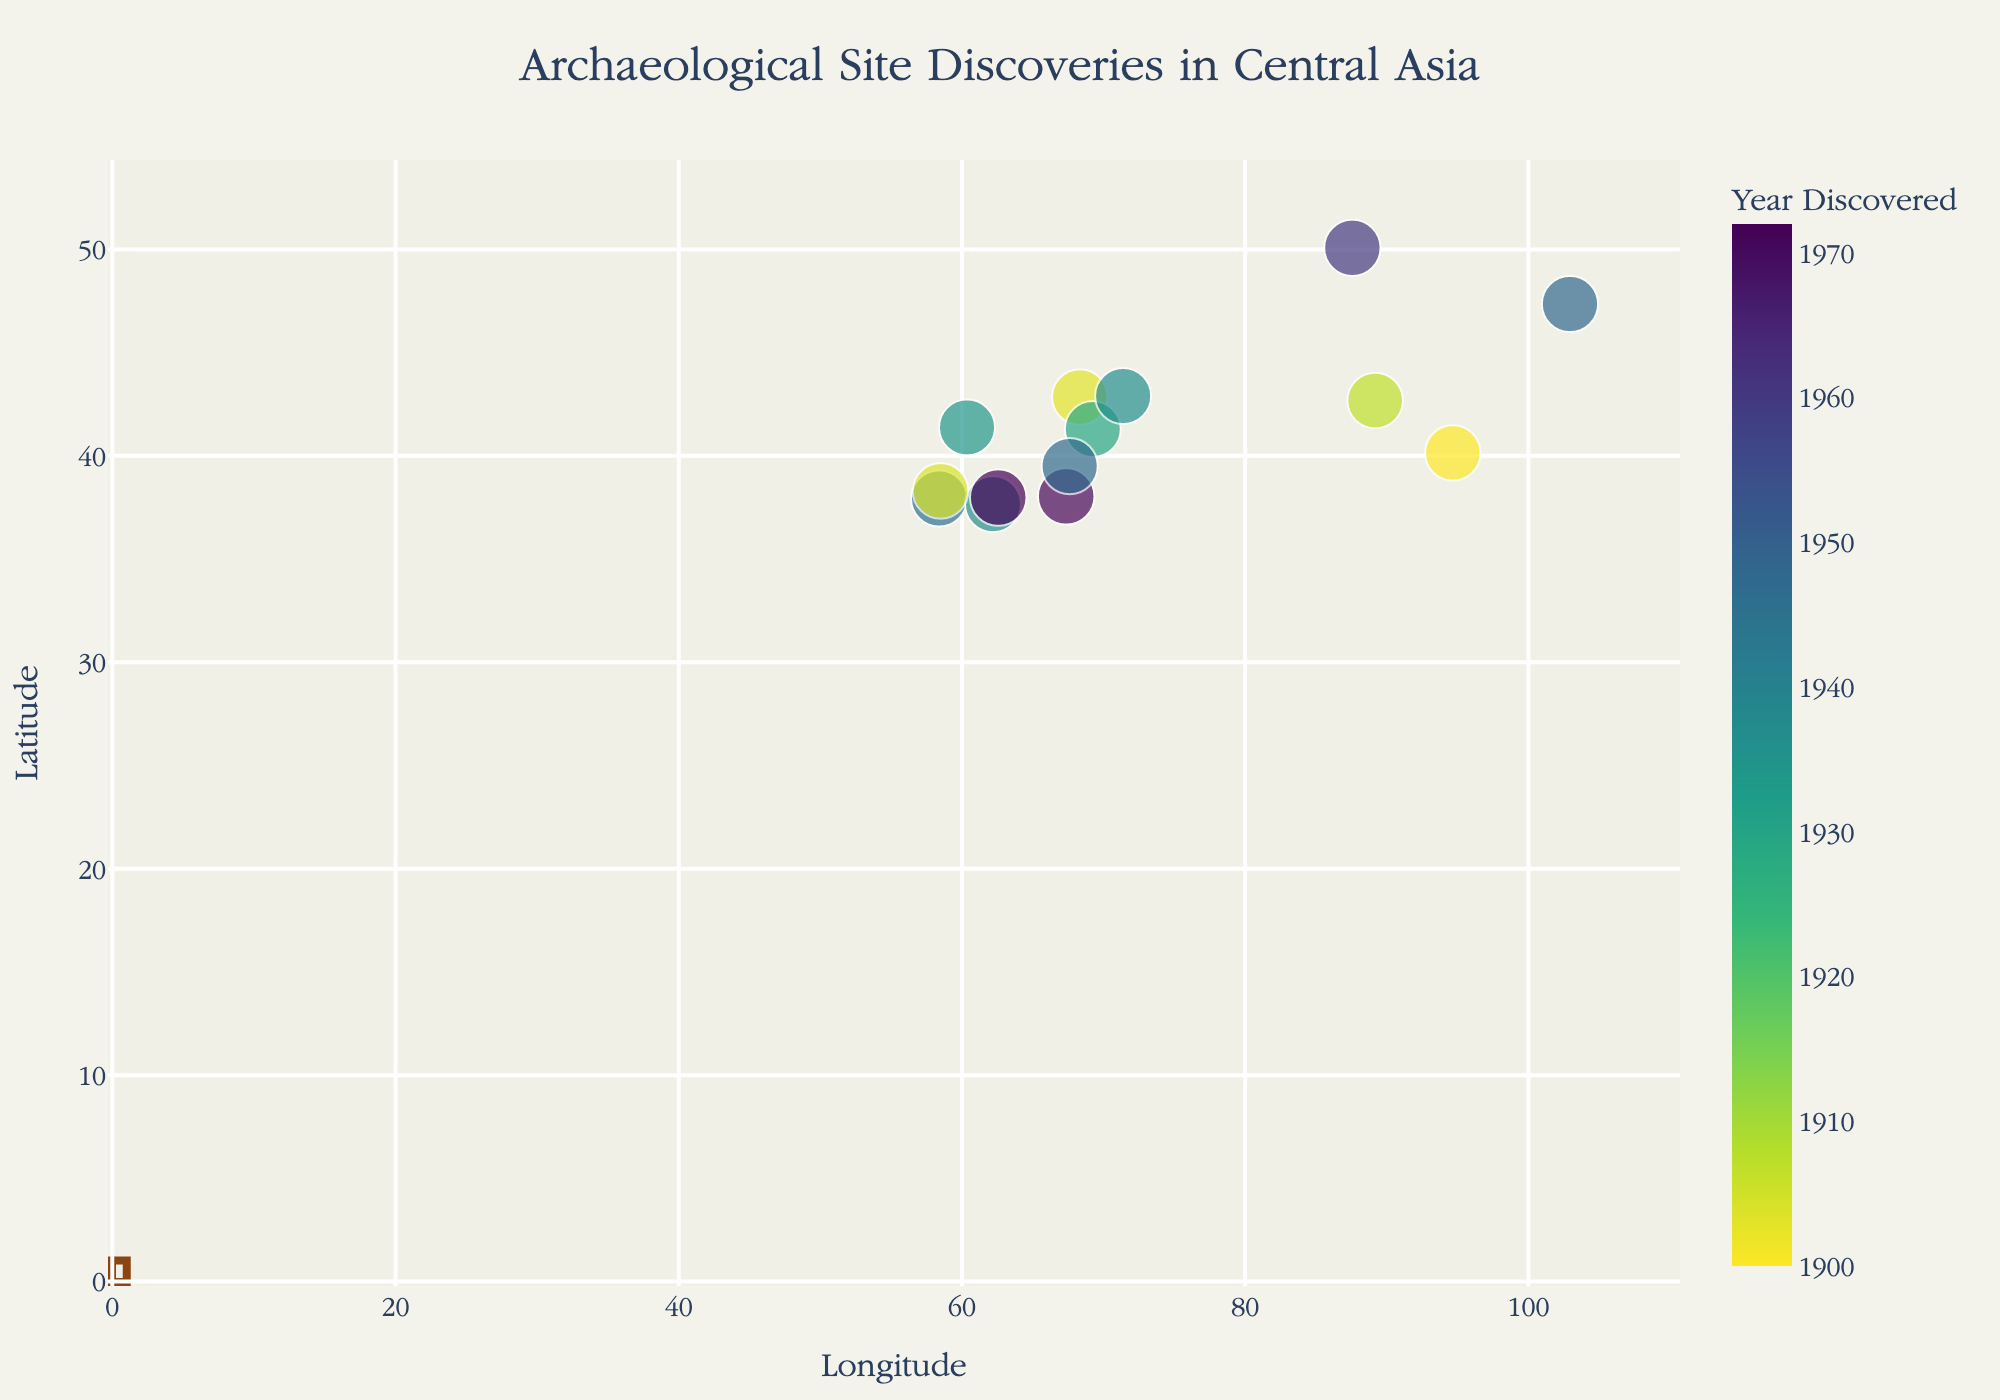How many archaeological sites are represented in the scatter plot? Count the number of data points in the plot. Each data point represents an archaeological site.
Answer: 14 What is the earliest year of discovery for the archaeological sites shown? Look for the data point with the lowest value on the color scale representing the earliest year discovered.
Answer: 1900 Which archaeological site is the farthest north in latitude? Identify the data point located at the highest position on the y-axis, as latitude increases northward.
Answer: Aktru Glacier Which type of remains is most frequently discovered according to the scatter plot? Count the number of occurrences of each type of remains indicated in the hover data.
Answer: City Ruins Which archaeological site discovered in the 1970s is located at the highest latitude? Filter the data points to those discovered in the 1970s and look for the one with the highest y-axis value.
Answer: Jarkutan How many archaeological sites were discovered before 1930? Filter the data points based on the color scale representing discoveries before 1930 and count them.
Answer: 4 Is there a correlation between longitude and the year of discovery? Observe if there is any pattern in the distribution of data points along the x-axis relative to the color gradient representing the year of discovery.
Answer: No clear correlation Which site discovered after 1950 is closest to the median longitude? Identify the median value of longitude from the dataset and find the site discovered after 1950 closest to this longitude value.
Answer: Aktru Glacier What is the latitude range of the archaeological sites discovered before 1950? Determine the highest and lowest latitude values among the sites discovered before 1950.
Answer: 37.661 to 50.0775 How does the geographic distribution of city ruins compare to settlements? Identify and compare the positions of data points labeled as "City Ruins" and "Settlement" on the scatter plot.
Answer: City ruins are more scattered across the map, while settlements are clustered 